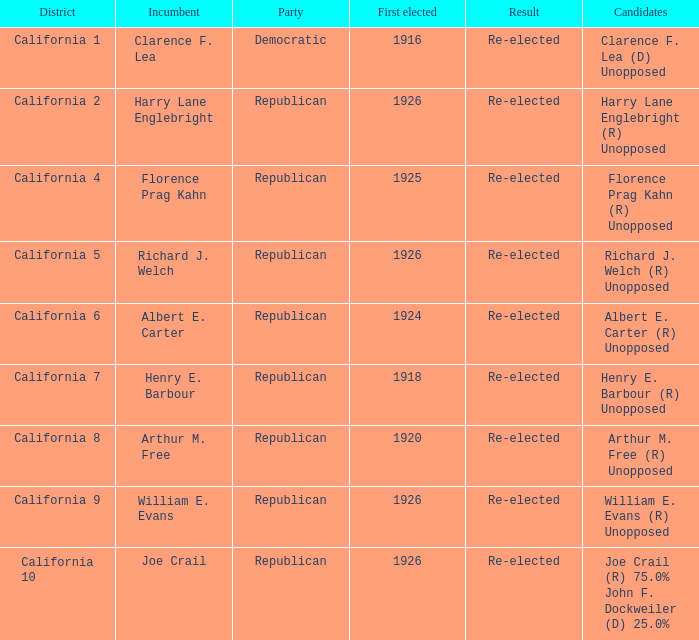What's the party with incumbent being william e. evans Republican. 